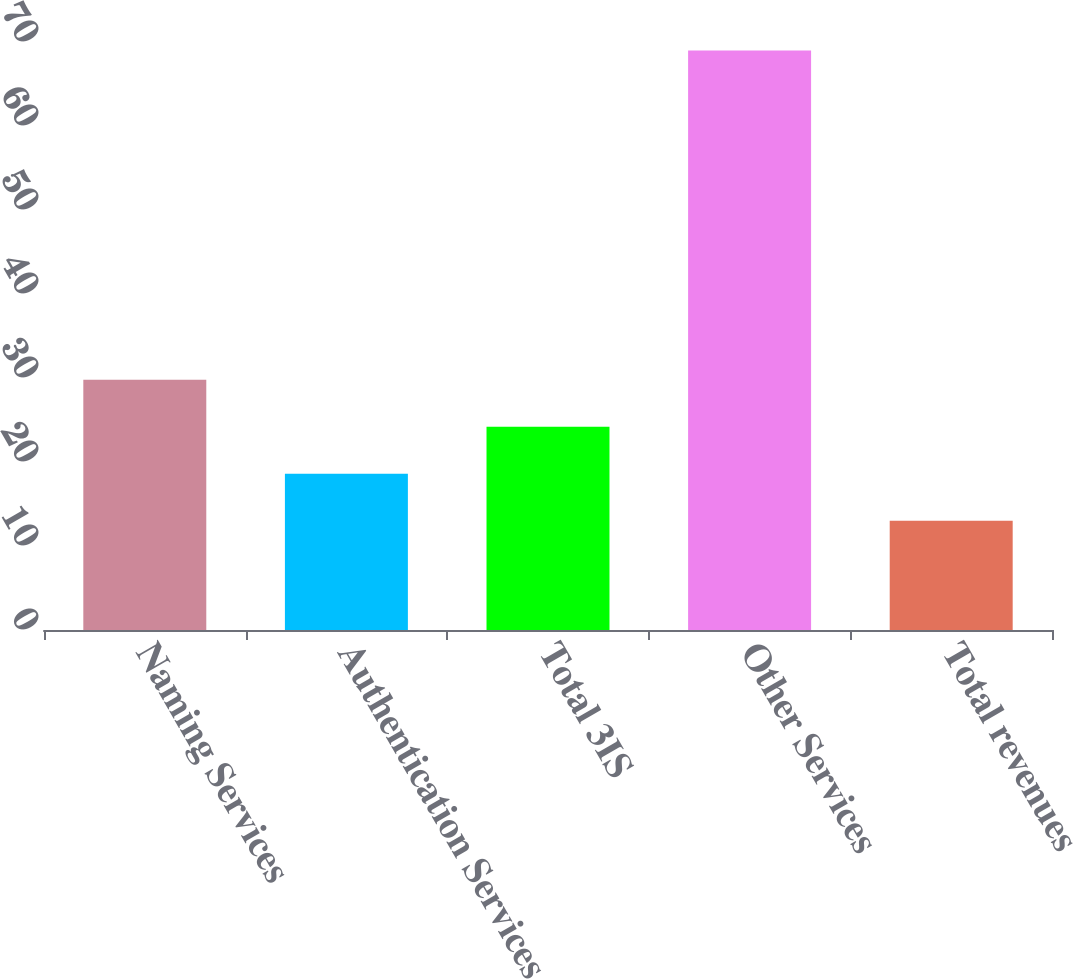Convert chart to OTSL. <chart><loc_0><loc_0><loc_500><loc_500><bar_chart><fcel>Naming Services<fcel>Authentication Services<fcel>Total 3IS<fcel>Other Services<fcel>Total revenues<nl><fcel>29.8<fcel>18.6<fcel>24.2<fcel>69<fcel>13<nl></chart> 